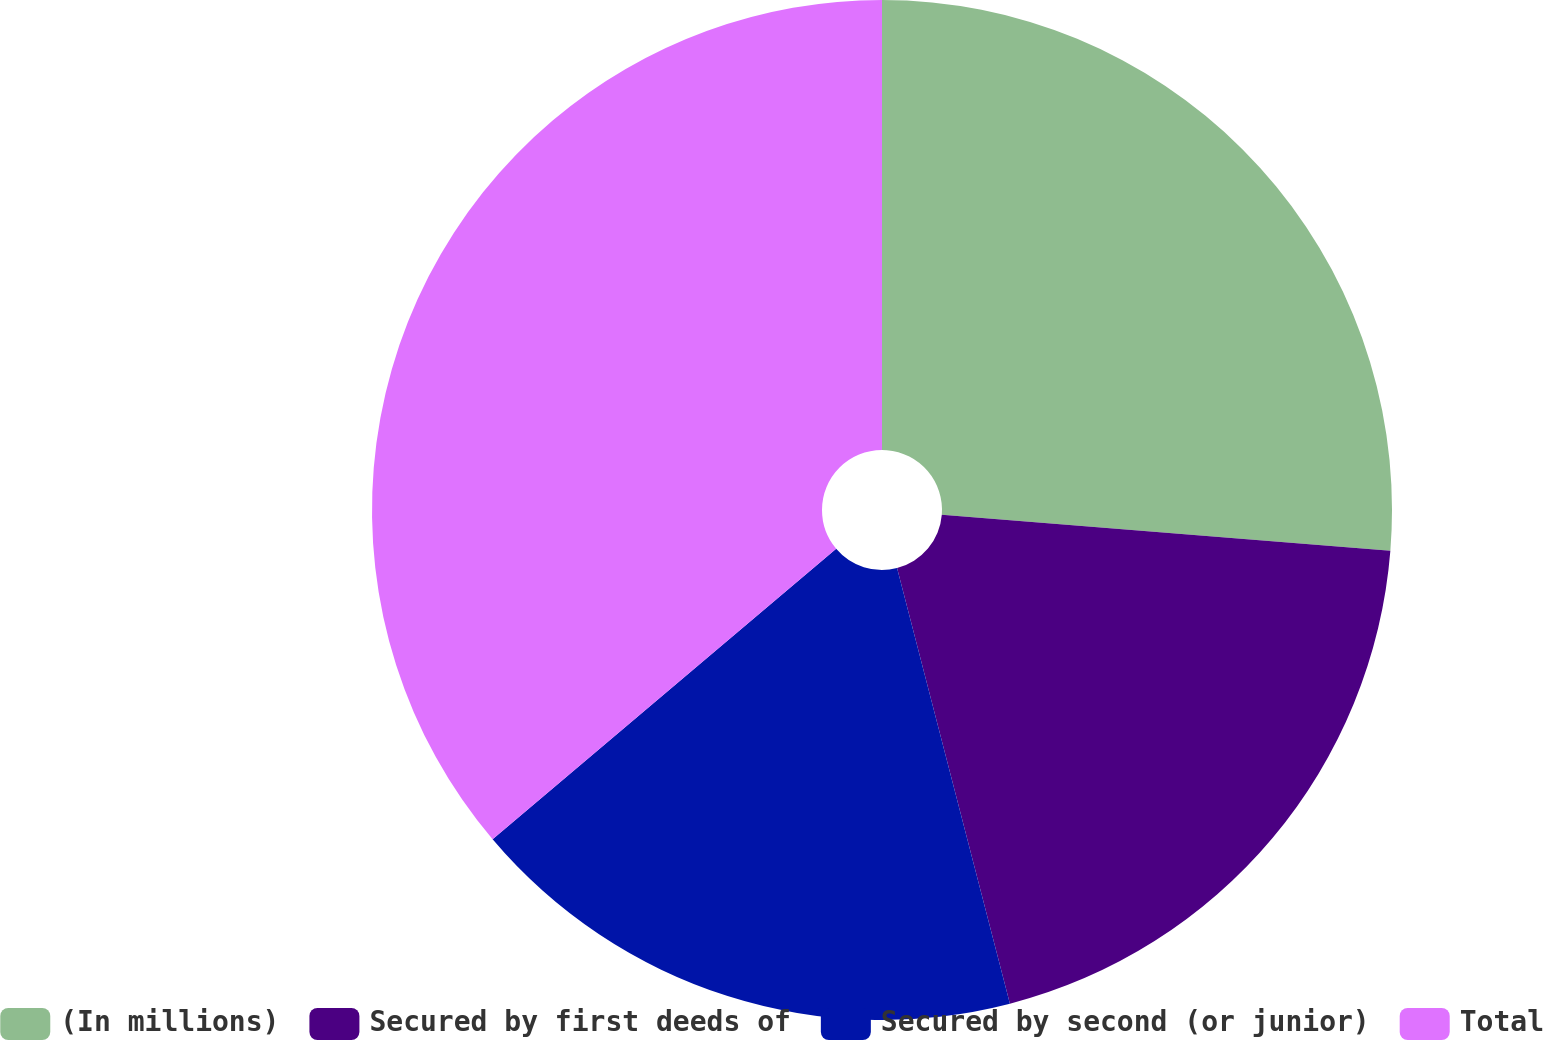Convert chart to OTSL. <chart><loc_0><loc_0><loc_500><loc_500><pie_chart><fcel>(In millions)<fcel>Secured by first deeds of<fcel>Secured by second (or junior)<fcel>Total<nl><fcel>26.27%<fcel>19.69%<fcel>17.86%<fcel>36.17%<nl></chart> 